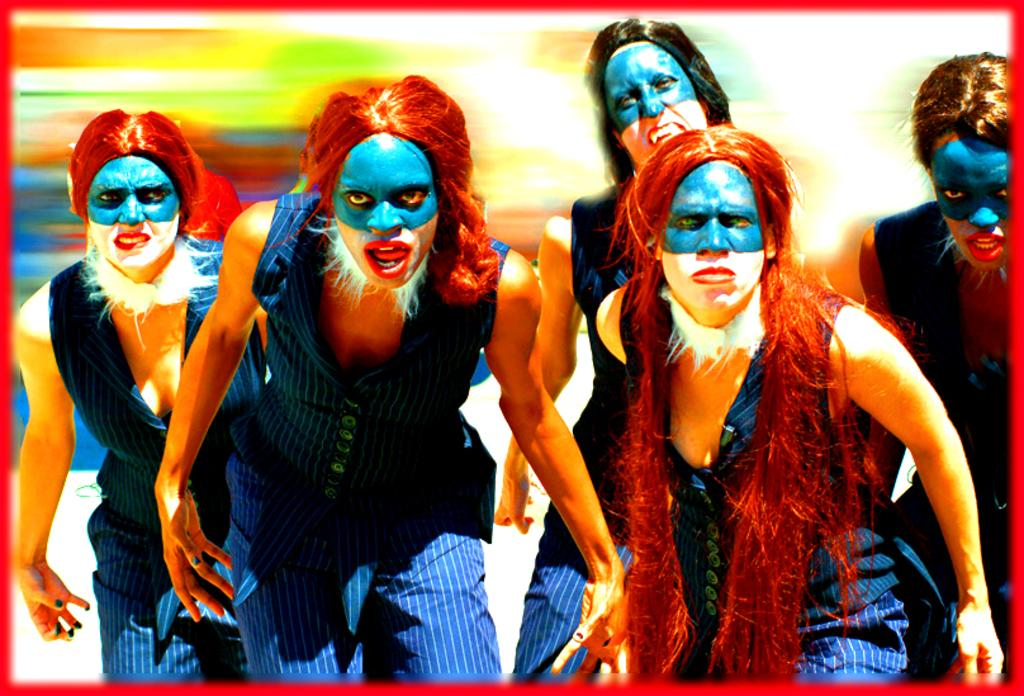How many people are present in the image? There are five persons in the image. What can be observed on the faces of the persons? The persons have face paintings. Can you describe the background of the image? The background of the image is blurred. What type of engine can be seen powering the match in the image? There is no engine or match present in the image. 